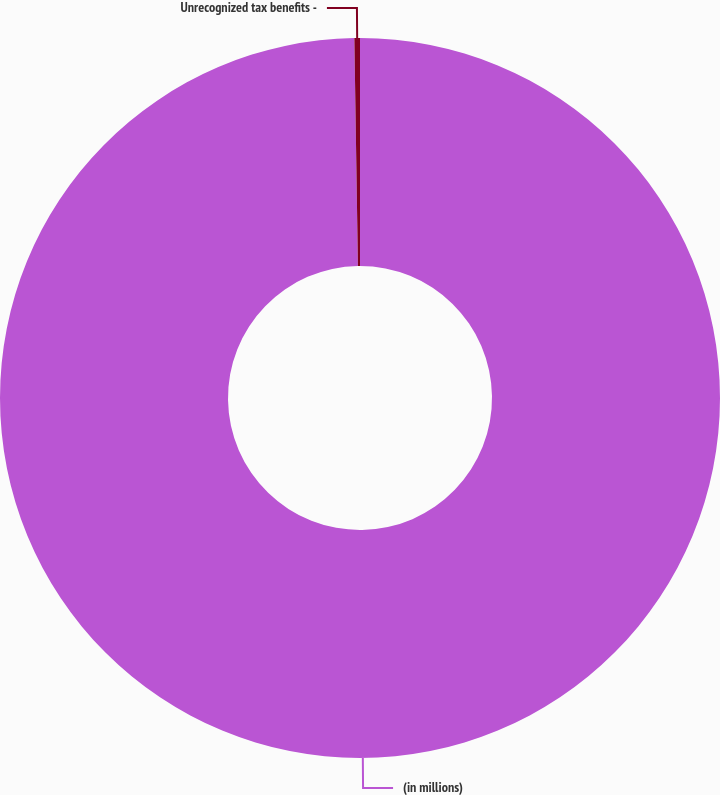<chart> <loc_0><loc_0><loc_500><loc_500><pie_chart><fcel>(in millions)<fcel>Unrecognized tax benefits -<nl><fcel>99.75%<fcel>0.25%<nl></chart> 